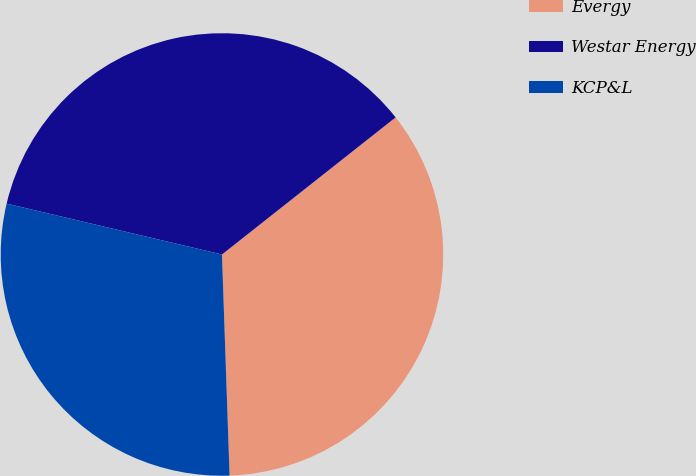<chart> <loc_0><loc_0><loc_500><loc_500><pie_chart><fcel>Evergy<fcel>Westar Energy<fcel>KCP&L<nl><fcel>35.09%<fcel>35.67%<fcel>29.24%<nl></chart> 